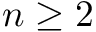<formula> <loc_0><loc_0><loc_500><loc_500>n \geq 2</formula> 